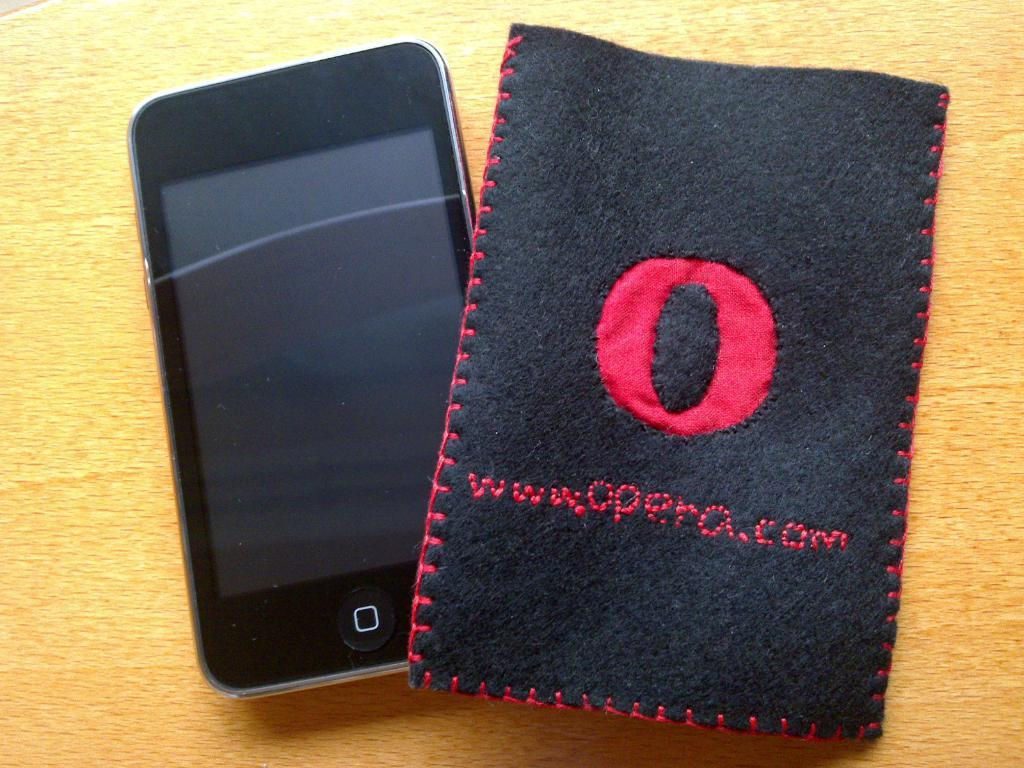<image>
Share a concise interpretation of the image provided. A cell phone a cloth protective case with a giant O on the front of it. 